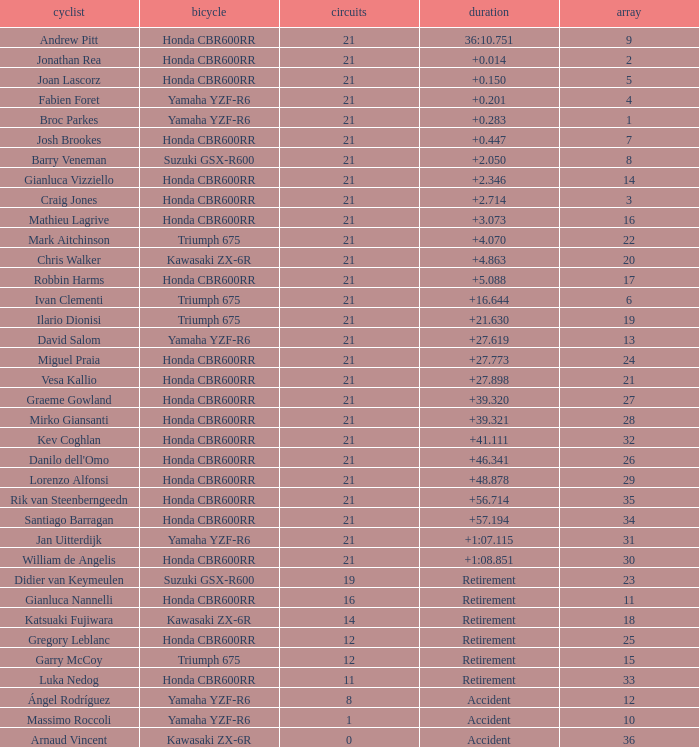What is the driver with the laps under 16, grid of 10, a bike of Yamaha YZF-R6, and ended with an accident? Massimo Roccoli. 